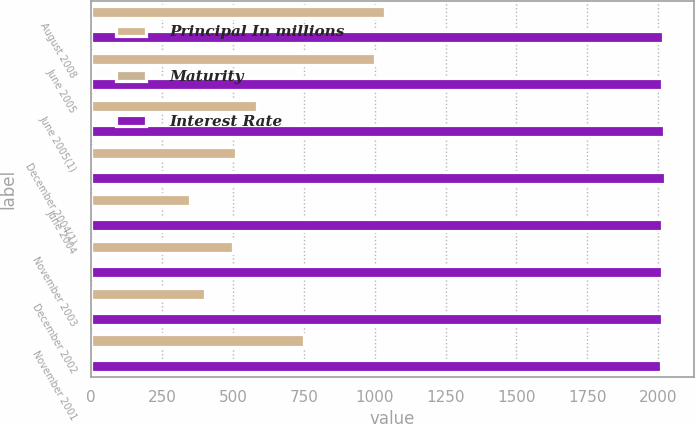<chart> <loc_0><loc_0><loc_500><loc_500><stacked_bar_chart><ecel><fcel>August 2008<fcel>June 2005<fcel>June 2005(1)<fcel>December 2004(1)<fcel>June 2004<fcel>November 2003<fcel>December 2002<fcel>November 2001<nl><fcel>Principal In millions<fcel>1035<fcel>1000<fcel>585<fcel>512<fcel>350<fcel>500<fcel>400<fcel>750<nl><fcel>Maturity<fcel>6.82<fcel>5<fcel>5.25<fcel>5.38<fcel>5.5<fcel>5<fcel>5.38<fcel>6.13<nl><fcel>Interest Rate<fcel>2018<fcel>2015<fcel>2020<fcel>2024<fcel>2014<fcel>2013<fcel>2012<fcel>2011<nl></chart> 